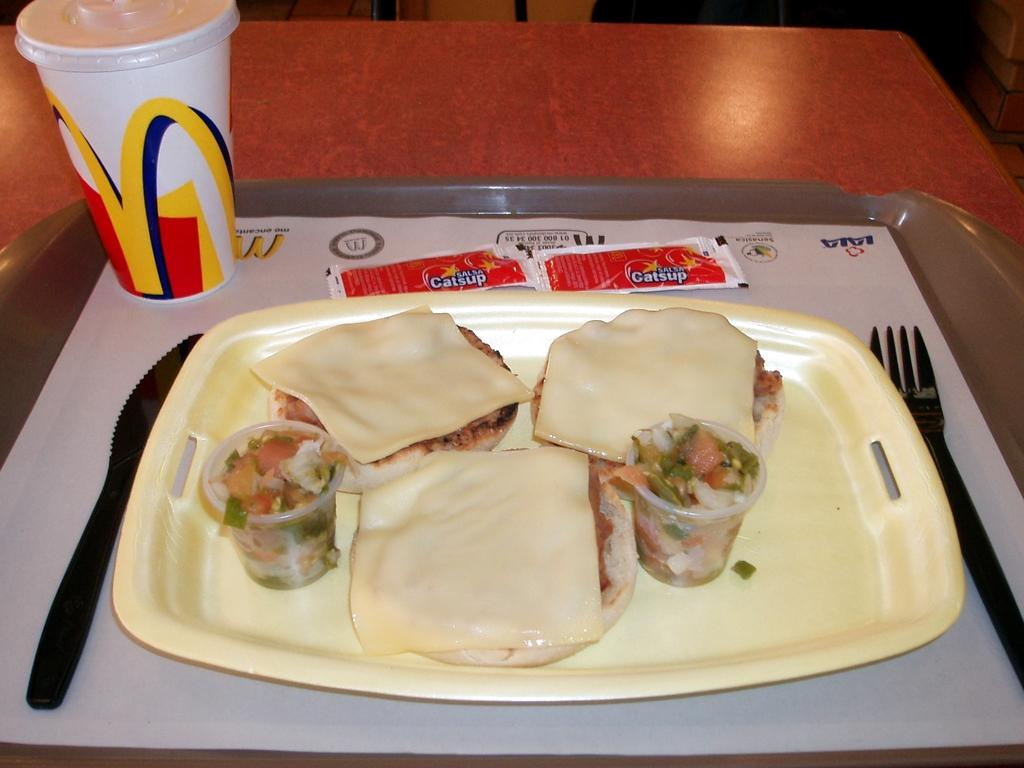What is on the table in the image? There is a tray on the table in the image. What can be found on the tray? There is a cup, a fork, a plastic knife, paste, bread, salad, a burger, and other food items on the tray. What type of utensils are present on the tray? There is a fork and a plastic knife on the tray. What food items are on the tray? There is bread, salad, and a burger on the tray. Are there any other food items on the tray? Yes, there are other food items on the tray. Is there any seating in the image? There is a chair on the top of the image. How many cherries are on the tray? There are no cherries present on the tray in the image. 